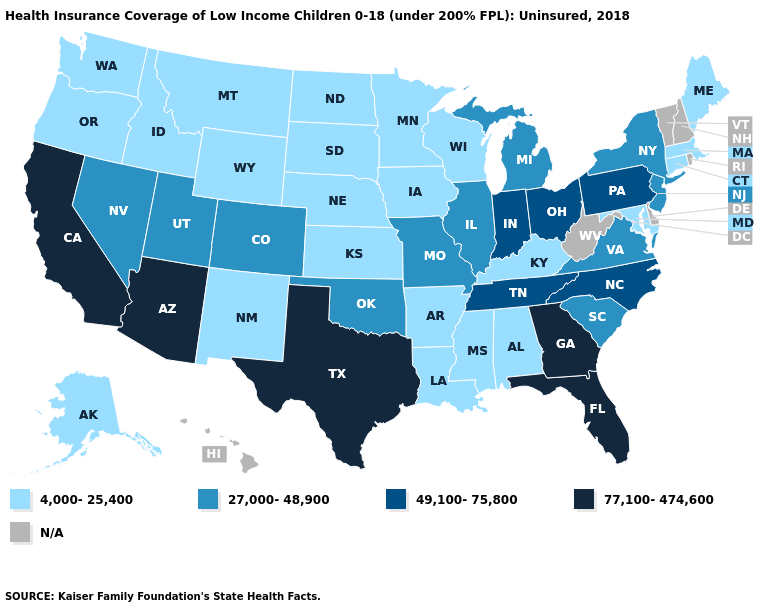What is the highest value in the USA?
Answer briefly. 77,100-474,600. What is the value of Colorado?
Concise answer only. 27,000-48,900. Does the map have missing data?
Concise answer only. Yes. What is the highest value in states that border New Hampshire?
Keep it brief. 4,000-25,400. Does Missouri have the lowest value in the USA?
Answer briefly. No. What is the value of New Mexico?
Quick response, please. 4,000-25,400. What is the value of Hawaii?
Keep it brief. N/A. Among the states that border Wyoming , does South Dakota have the lowest value?
Be succinct. Yes. What is the value of Georgia?
Quick response, please. 77,100-474,600. Among the states that border Maryland , does Virginia have the lowest value?
Keep it brief. Yes. What is the highest value in the South ?
Be succinct. 77,100-474,600. Which states have the highest value in the USA?
Quick response, please. Arizona, California, Florida, Georgia, Texas. Does the first symbol in the legend represent the smallest category?
Write a very short answer. Yes. Name the states that have a value in the range 49,100-75,800?
Quick response, please. Indiana, North Carolina, Ohio, Pennsylvania, Tennessee. 